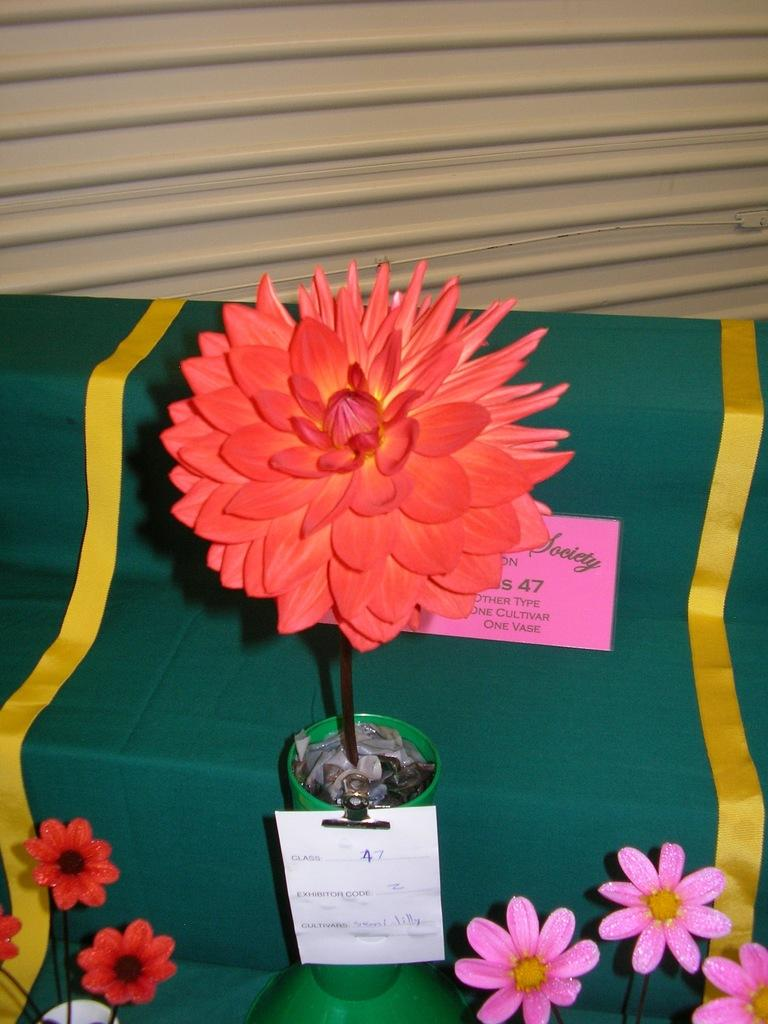What type of furniture is present in the image? There is a table in the image. What is covering the table? There is a cloth on the table. What decorative items can be seen on the cloth? There are flower vases on the cloth. What can be seen in the background of the image? There is a shutter in the background of the image. Can you see the sea in the background of the image? No, there is no sea visible in the image; it features a shutter in the background. 